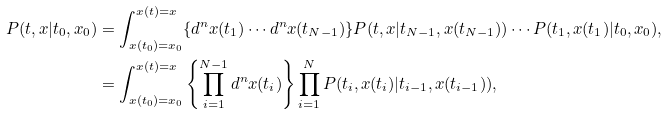<formula> <loc_0><loc_0><loc_500><loc_500>P ( t , x | t _ { 0 } , x _ { 0 } ) & = \int _ { x ( t _ { 0 } ) = x _ { 0 } } ^ { x ( t ) = x } \{ d ^ { n } x ( t _ { 1 } ) \cdots d ^ { n } x ( t _ { N - 1 } ) \} P ( t , x | t _ { N - 1 } , x ( t _ { N - 1 } ) ) \cdots P ( t _ { 1 } , x ( t _ { 1 } ) | t _ { 0 } , x _ { 0 } ) , \\ & = \int _ { x ( t _ { 0 } ) = x _ { 0 } } ^ { x ( t ) = x } \left \{ \prod _ { i = 1 } ^ { N - 1 } d ^ { n } x ( t _ { i } ) \right \} \prod _ { i = 1 } ^ { N } P ( t _ { i } , x ( t _ { i } ) | t _ { i - 1 } , x ( t _ { i - 1 } ) ) ,</formula> 